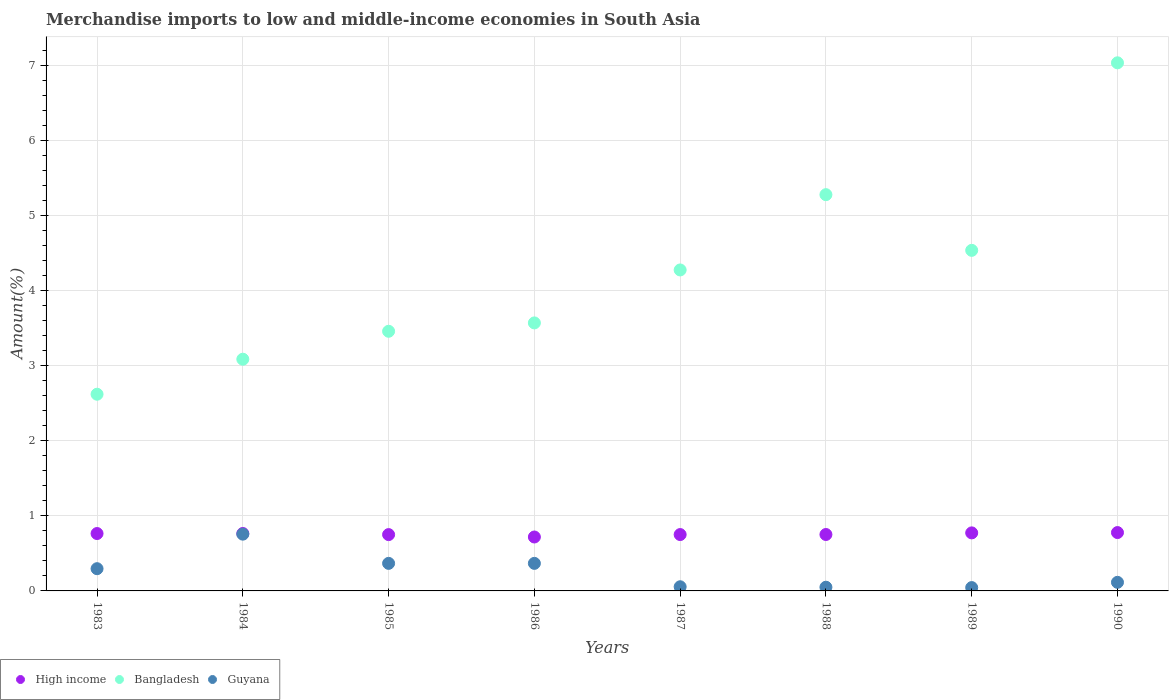What is the percentage of amount earned from merchandise imports in Guyana in 1985?
Give a very brief answer. 0.37. Across all years, what is the maximum percentage of amount earned from merchandise imports in Guyana?
Keep it short and to the point. 0.76. Across all years, what is the minimum percentage of amount earned from merchandise imports in Guyana?
Ensure brevity in your answer.  0.04. In which year was the percentage of amount earned from merchandise imports in Guyana maximum?
Make the answer very short. 1984. What is the total percentage of amount earned from merchandise imports in Bangladesh in the graph?
Your answer should be compact. 33.88. What is the difference between the percentage of amount earned from merchandise imports in High income in 1985 and that in 1990?
Your answer should be compact. -0.03. What is the difference between the percentage of amount earned from merchandise imports in Bangladesh in 1985 and the percentage of amount earned from merchandise imports in Guyana in 1986?
Your answer should be compact. 3.09. What is the average percentage of amount earned from merchandise imports in Guyana per year?
Provide a short and direct response. 0.26. In the year 1988, what is the difference between the percentage of amount earned from merchandise imports in High income and percentage of amount earned from merchandise imports in Guyana?
Offer a terse response. 0.7. In how many years, is the percentage of amount earned from merchandise imports in High income greater than 2.6 %?
Give a very brief answer. 0. What is the ratio of the percentage of amount earned from merchandise imports in Guyana in 1986 to that in 1990?
Your response must be concise. 3.21. Is the percentage of amount earned from merchandise imports in Bangladesh in 1984 less than that in 1986?
Offer a very short reply. Yes. Is the difference between the percentage of amount earned from merchandise imports in High income in 1985 and 1986 greater than the difference between the percentage of amount earned from merchandise imports in Guyana in 1985 and 1986?
Provide a succinct answer. Yes. What is the difference between the highest and the second highest percentage of amount earned from merchandise imports in Bangladesh?
Keep it short and to the point. 1.76. What is the difference between the highest and the lowest percentage of amount earned from merchandise imports in Guyana?
Your response must be concise. 0.71. Is the sum of the percentage of amount earned from merchandise imports in Bangladesh in 1984 and 1988 greater than the maximum percentage of amount earned from merchandise imports in Guyana across all years?
Offer a terse response. Yes. Is it the case that in every year, the sum of the percentage of amount earned from merchandise imports in High income and percentage of amount earned from merchandise imports in Bangladesh  is greater than the percentage of amount earned from merchandise imports in Guyana?
Your response must be concise. Yes. Does the percentage of amount earned from merchandise imports in Guyana monotonically increase over the years?
Make the answer very short. No. Is the percentage of amount earned from merchandise imports in Bangladesh strictly greater than the percentage of amount earned from merchandise imports in High income over the years?
Offer a terse response. Yes. Is the percentage of amount earned from merchandise imports in High income strictly less than the percentage of amount earned from merchandise imports in Guyana over the years?
Ensure brevity in your answer.  No. How many dotlines are there?
Keep it short and to the point. 3. How many years are there in the graph?
Make the answer very short. 8. Are the values on the major ticks of Y-axis written in scientific E-notation?
Make the answer very short. No. Where does the legend appear in the graph?
Provide a short and direct response. Bottom left. How are the legend labels stacked?
Make the answer very short. Horizontal. What is the title of the graph?
Make the answer very short. Merchandise imports to low and middle-income economies in South Asia. What is the label or title of the Y-axis?
Make the answer very short. Amount(%). What is the Amount(%) of High income in 1983?
Make the answer very short. 0.76. What is the Amount(%) of Bangladesh in 1983?
Your answer should be compact. 2.62. What is the Amount(%) of Guyana in 1983?
Provide a short and direct response. 0.3. What is the Amount(%) in High income in 1984?
Your response must be concise. 0.77. What is the Amount(%) in Bangladesh in 1984?
Your response must be concise. 3.09. What is the Amount(%) of Guyana in 1984?
Provide a short and direct response. 0.76. What is the Amount(%) of High income in 1985?
Offer a very short reply. 0.75. What is the Amount(%) in Bangladesh in 1985?
Keep it short and to the point. 3.46. What is the Amount(%) of Guyana in 1985?
Ensure brevity in your answer.  0.37. What is the Amount(%) of High income in 1986?
Make the answer very short. 0.72. What is the Amount(%) of Bangladesh in 1986?
Your response must be concise. 3.57. What is the Amount(%) in Guyana in 1986?
Your response must be concise. 0.37. What is the Amount(%) in High income in 1987?
Your response must be concise. 0.75. What is the Amount(%) of Bangladesh in 1987?
Your answer should be compact. 4.28. What is the Amount(%) in Guyana in 1987?
Provide a succinct answer. 0.06. What is the Amount(%) of High income in 1988?
Your answer should be compact. 0.75. What is the Amount(%) in Bangladesh in 1988?
Provide a short and direct response. 5.28. What is the Amount(%) of Guyana in 1988?
Offer a very short reply. 0.05. What is the Amount(%) in High income in 1989?
Provide a short and direct response. 0.77. What is the Amount(%) of Bangladesh in 1989?
Give a very brief answer. 4.54. What is the Amount(%) of Guyana in 1989?
Offer a terse response. 0.04. What is the Amount(%) in High income in 1990?
Your answer should be very brief. 0.78. What is the Amount(%) of Bangladesh in 1990?
Make the answer very short. 7.04. What is the Amount(%) in Guyana in 1990?
Ensure brevity in your answer.  0.11. Across all years, what is the maximum Amount(%) of High income?
Provide a short and direct response. 0.78. Across all years, what is the maximum Amount(%) in Bangladesh?
Keep it short and to the point. 7.04. Across all years, what is the maximum Amount(%) of Guyana?
Give a very brief answer. 0.76. Across all years, what is the minimum Amount(%) of High income?
Provide a short and direct response. 0.72. Across all years, what is the minimum Amount(%) of Bangladesh?
Offer a terse response. 2.62. Across all years, what is the minimum Amount(%) of Guyana?
Offer a very short reply. 0.04. What is the total Amount(%) in High income in the graph?
Offer a terse response. 6.05. What is the total Amount(%) of Bangladesh in the graph?
Ensure brevity in your answer.  33.88. What is the total Amount(%) in Guyana in the graph?
Offer a terse response. 2.05. What is the difference between the Amount(%) in High income in 1983 and that in 1984?
Keep it short and to the point. -0. What is the difference between the Amount(%) of Bangladesh in 1983 and that in 1984?
Give a very brief answer. -0.47. What is the difference between the Amount(%) in Guyana in 1983 and that in 1984?
Your answer should be compact. -0.46. What is the difference between the Amount(%) in High income in 1983 and that in 1985?
Make the answer very short. 0.01. What is the difference between the Amount(%) in Bangladesh in 1983 and that in 1985?
Provide a short and direct response. -0.84. What is the difference between the Amount(%) of Guyana in 1983 and that in 1985?
Keep it short and to the point. -0.07. What is the difference between the Amount(%) of High income in 1983 and that in 1986?
Your answer should be very brief. 0.05. What is the difference between the Amount(%) in Bangladesh in 1983 and that in 1986?
Offer a very short reply. -0.95. What is the difference between the Amount(%) of Guyana in 1983 and that in 1986?
Offer a terse response. -0.07. What is the difference between the Amount(%) in High income in 1983 and that in 1987?
Ensure brevity in your answer.  0.01. What is the difference between the Amount(%) in Bangladesh in 1983 and that in 1987?
Provide a short and direct response. -1.66. What is the difference between the Amount(%) of Guyana in 1983 and that in 1987?
Give a very brief answer. 0.24. What is the difference between the Amount(%) of High income in 1983 and that in 1988?
Your response must be concise. 0.01. What is the difference between the Amount(%) of Bangladesh in 1983 and that in 1988?
Offer a very short reply. -2.66. What is the difference between the Amount(%) in Guyana in 1983 and that in 1988?
Give a very brief answer. 0.25. What is the difference between the Amount(%) in High income in 1983 and that in 1989?
Make the answer very short. -0.01. What is the difference between the Amount(%) of Bangladesh in 1983 and that in 1989?
Your response must be concise. -1.92. What is the difference between the Amount(%) of Guyana in 1983 and that in 1989?
Offer a very short reply. 0.25. What is the difference between the Amount(%) in High income in 1983 and that in 1990?
Give a very brief answer. -0.01. What is the difference between the Amount(%) of Bangladesh in 1983 and that in 1990?
Your answer should be compact. -4.42. What is the difference between the Amount(%) of Guyana in 1983 and that in 1990?
Ensure brevity in your answer.  0.18. What is the difference between the Amount(%) of High income in 1984 and that in 1985?
Your answer should be compact. 0.01. What is the difference between the Amount(%) of Bangladesh in 1984 and that in 1985?
Your answer should be compact. -0.37. What is the difference between the Amount(%) of Guyana in 1984 and that in 1985?
Your response must be concise. 0.39. What is the difference between the Amount(%) in High income in 1984 and that in 1986?
Keep it short and to the point. 0.05. What is the difference between the Amount(%) in Bangladesh in 1984 and that in 1986?
Make the answer very short. -0.48. What is the difference between the Amount(%) in Guyana in 1984 and that in 1986?
Your response must be concise. 0.39. What is the difference between the Amount(%) in High income in 1984 and that in 1987?
Your response must be concise. 0.01. What is the difference between the Amount(%) in Bangladesh in 1984 and that in 1987?
Make the answer very short. -1.19. What is the difference between the Amount(%) in Guyana in 1984 and that in 1987?
Give a very brief answer. 0.7. What is the difference between the Amount(%) in High income in 1984 and that in 1988?
Ensure brevity in your answer.  0.01. What is the difference between the Amount(%) of Bangladesh in 1984 and that in 1988?
Provide a short and direct response. -2.19. What is the difference between the Amount(%) in Guyana in 1984 and that in 1988?
Your answer should be compact. 0.71. What is the difference between the Amount(%) in High income in 1984 and that in 1989?
Ensure brevity in your answer.  -0.01. What is the difference between the Amount(%) of Bangladesh in 1984 and that in 1989?
Give a very brief answer. -1.45. What is the difference between the Amount(%) of Guyana in 1984 and that in 1989?
Ensure brevity in your answer.  0.71. What is the difference between the Amount(%) of High income in 1984 and that in 1990?
Offer a terse response. -0.01. What is the difference between the Amount(%) of Bangladesh in 1984 and that in 1990?
Offer a very short reply. -3.95. What is the difference between the Amount(%) of Guyana in 1984 and that in 1990?
Offer a terse response. 0.64. What is the difference between the Amount(%) in High income in 1985 and that in 1986?
Offer a terse response. 0.03. What is the difference between the Amount(%) of Bangladesh in 1985 and that in 1986?
Keep it short and to the point. -0.11. What is the difference between the Amount(%) in High income in 1985 and that in 1987?
Provide a succinct answer. -0. What is the difference between the Amount(%) of Bangladesh in 1985 and that in 1987?
Your answer should be very brief. -0.82. What is the difference between the Amount(%) of Guyana in 1985 and that in 1987?
Provide a succinct answer. 0.31. What is the difference between the Amount(%) in High income in 1985 and that in 1988?
Offer a terse response. -0. What is the difference between the Amount(%) in Bangladesh in 1985 and that in 1988?
Make the answer very short. -1.82. What is the difference between the Amount(%) in Guyana in 1985 and that in 1988?
Provide a succinct answer. 0.32. What is the difference between the Amount(%) in High income in 1985 and that in 1989?
Make the answer very short. -0.02. What is the difference between the Amount(%) in Bangladesh in 1985 and that in 1989?
Your answer should be very brief. -1.08. What is the difference between the Amount(%) of Guyana in 1985 and that in 1989?
Make the answer very short. 0.32. What is the difference between the Amount(%) in High income in 1985 and that in 1990?
Provide a succinct answer. -0.03. What is the difference between the Amount(%) in Bangladesh in 1985 and that in 1990?
Your answer should be very brief. -3.58. What is the difference between the Amount(%) in Guyana in 1985 and that in 1990?
Give a very brief answer. 0.25. What is the difference between the Amount(%) in High income in 1986 and that in 1987?
Ensure brevity in your answer.  -0.03. What is the difference between the Amount(%) in Bangladesh in 1986 and that in 1987?
Provide a short and direct response. -0.71. What is the difference between the Amount(%) of Guyana in 1986 and that in 1987?
Provide a succinct answer. 0.31. What is the difference between the Amount(%) of High income in 1986 and that in 1988?
Provide a succinct answer. -0.03. What is the difference between the Amount(%) of Bangladesh in 1986 and that in 1988?
Provide a succinct answer. -1.71. What is the difference between the Amount(%) in Guyana in 1986 and that in 1988?
Offer a very short reply. 0.32. What is the difference between the Amount(%) of High income in 1986 and that in 1989?
Ensure brevity in your answer.  -0.05. What is the difference between the Amount(%) in Bangladesh in 1986 and that in 1989?
Offer a terse response. -0.97. What is the difference between the Amount(%) in Guyana in 1986 and that in 1989?
Your response must be concise. 0.32. What is the difference between the Amount(%) in High income in 1986 and that in 1990?
Keep it short and to the point. -0.06. What is the difference between the Amount(%) of Bangladesh in 1986 and that in 1990?
Your answer should be very brief. -3.47. What is the difference between the Amount(%) of Guyana in 1986 and that in 1990?
Keep it short and to the point. 0.25. What is the difference between the Amount(%) in High income in 1987 and that in 1988?
Make the answer very short. -0. What is the difference between the Amount(%) of Bangladesh in 1987 and that in 1988?
Provide a short and direct response. -1. What is the difference between the Amount(%) in Guyana in 1987 and that in 1988?
Your answer should be compact. 0.01. What is the difference between the Amount(%) of High income in 1987 and that in 1989?
Ensure brevity in your answer.  -0.02. What is the difference between the Amount(%) in Bangladesh in 1987 and that in 1989?
Offer a very short reply. -0.26. What is the difference between the Amount(%) of Guyana in 1987 and that in 1989?
Your answer should be very brief. 0.01. What is the difference between the Amount(%) of High income in 1987 and that in 1990?
Keep it short and to the point. -0.03. What is the difference between the Amount(%) of Bangladesh in 1987 and that in 1990?
Your answer should be compact. -2.76. What is the difference between the Amount(%) of Guyana in 1987 and that in 1990?
Your answer should be compact. -0.06. What is the difference between the Amount(%) in High income in 1988 and that in 1989?
Provide a short and direct response. -0.02. What is the difference between the Amount(%) of Bangladesh in 1988 and that in 1989?
Offer a terse response. 0.74. What is the difference between the Amount(%) in Guyana in 1988 and that in 1989?
Offer a terse response. 0. What is the difference between the Amount(%) of High income in 1988 and that in 1990?
Make the answer very short. -0.03. What is the difference between the Amount(%) in Bangladesh in 1988 and that in 1990?
Your response must be concise. -1.76. What is the difference between the Amount(%) of Guyana in 1988 and that in 1990?
Your answer should be very brief. -0.07. What is the difference between the Amount(%) of High income in 1989 and that in 1990?
Your response must be concise. -0. What is the difference between the Amount(%) in Bangladesh in 1989 and that in 1990?
Your response must be concise. -2.5. What is the difference between the Amount(%) of Guyana in 1989 and that in 1990?
Your answer should be compact. -0.07. What is the difference between the Amount(%) in High income in 1983 and the Amount(%) in Bangladesh in 1984?
Offer a terse response. -2.32. What is the difference between the Amount(%) of High income in 1983 and the Amount(%) of Guyana in 1984?
Offer a very short reply. 0.01. What is the difference between the Amount(%) in Bangladesh in 1983 and the Amount(%) in Guyana in 1984?
Ensure brevity in your answer.  1.86. What is the difference between the Amount(%) in High income in 1983 and the Amount(%) in Bangladesh in 1985?
Provide a succinct answer. -2.7. What is the difference between the Amount(%) of High income in 1983 and the Amount(%) of Guyana in 1985?
Make the answer very short. 0.4. What is the difference between the Amount(%) of Bangladesh in 1983 and the Amount(%) of Guyana in 1985?
Provide a succinct answer. 2.25. What is the difference between the Amount(%) of High income in 1983 and the Amount(%) of Bangladesh in 1986?
Give a very brief answer. -2.81. What is the difference between the Amount(%) in High income in 1983 and the Amount(%) in Guyana in 1986?
Offer a terse response. 0.4. What is the difference between the Amount(%) of Bangladesh in 1983 and the Amount(%) of Guyana in 1986?
Provide a short and direct response. 2.25. What is the difference between the Amount(%) of High income in 1983 and the Amount(%) of Bangladesh in 1987?
Make the answer very short. -3.51. What is the difference between the Amount(%) of High income in 1983 and the Amount(%) of Guyana in 1987?
Your response must be concise. 0.71. What is the difference between the Amount(%) in Bangladesh in 1983 and the Amount(%) in Guyana in 1987?
Your response must be concise. 2.57. What is the difference between the Amount(%) of High income in 1983 and the Amount(%) of Bangladesh in 1988?
Provide a short and direct response. -4.52. What is the difference between the Amount(%) in High income in 1983 and the Amount(%) in Guyana in 1988?
Offer a very short reply. 0.72. What is the difference between the Amount(%) in Bangladesh in 1983 and the Amount(%) in Guyana in 1988?
Provide a short and direct response. 2.57. What is the difference between the Amount(%) of High income in 1983 and the Amount(%) of Bangladesh in 1989?
Ensure brevity in your answer.  -3.77. What is the difference between the Amount(%) in High income in 1983 and the Amount(%) in Guyana in 1989?
Keep it short and to the point. 0.72. What is the difference between the Amount(%) of Bangladesh in 1983 and the Amount(%) of Guyana in 1989?
Offer a very short reply. 2.58. What is the difference between the Amount(%) in High income in 1983 and the Amount(%) in Bangladesh in 1990?
Your answer should be compact. -6.27. What is the difference between the Amount(%) of High income in 1983 and the Amount(%) of Guyana in 1990?
Your answer should be very brief. 0.65. What is the difference between the Amount(%) in Bangladesh in 1983 and the Amount(%) in Guyana in 1990?
Keep it short and to the point. 2.51. What is the difference between the Amount(%) of High income in 1984 and the Amount(%) of Bangladesh in 1985?
Make the answer very short. -2.7. What is the difference between the Amount(%) in High income in 1984 and the Amount(%) in Guyana in 1985?
Offer a very short reply. 0.4. What is the difference between the Amount(%) in Bangladesh in 1984 and the Amount(%) in Guyana in 1985?
Offer a very short reply. 2.72. What is the difference between the Amount(%) in High income in 1984 and the Amount(%) in Bangladesh in 1986?
Your answer should be compact. -2.81. What is the difference between the Amount(%) in High income in 1984 and the Amount(%) in Guyana in 1986?
Give a very brief answer. 0.4. What is the difference between the Amount(%) of Bangladesh in 1984 and the Amount(%) of Guyana in 1986?
Give a very brief answer. 2.72. What is the difference between the Amount(%) of High income in 1984 and the Amount(%) of Bangladesh in 1987?
Give a very brief answer. -3.51. What is the difference between the Amount(%) of High income in 1984 and the Amount(%) of Guyana in 1987?
Keep it short and to the point. 0.71. What is the difference between the Amount(%) in Bangladesh in 1984 and the Amount(%) in Guyana in 1987?
Make the answer very short. 3.03. What is the difference between the Amount(%) of High income in 1984 and the Amount(%) of Bangladesh in 1988?
Your answer should be compact. -4.52. What is the difference between the Amount(%) in High income in 1984 and the Amount(%) in Guyana in 1988?
Make the answer very short. 0.72. What is the difference between the Amount(%) of Bangladesh in 1984 and the Amount(%) of Guyana in 1988?
Your answer should be compact. 3.04. What is the difference between the Amount(%) of High income in 1984 and the Amount(%) of Bangladesh in 1989?
Make the answer very short. -3.77. What is the difference between the Amount(%) of High income in 1984 and the Amount(%) of Guyana in 1989?
Ensure brevity in your answer.  0.72. What is the difference between the Amount(%) in Bangladesh in 1984 and the Amount(%) in Guyana in 1989?
Give a very brief answer. 3.04. What is the difference between the Amount(%) of High income in 1984 and the Amount(%) of Bangladesh in 1990?
Offer a very short reply. -6.27. What is the difference between the Amount(%) in High income in 1984 and the Amount(%) in Guyana in 1990?
Keep it short and to the point. 0.65. What is the difference between the Amount(%) of Bangladesh in 1984 and the Amount(%) of Guyana in 1990?
Your answer should be very brief. 2.97. What is the difference between the Amount(%) in High income in 1985 and the Amount(%) in Bangladesh in 1986?
Keep it short and to the point. -2.82. What is the difference between the Amount(%) of High income in 1985 and the Amount(%) of Guyana in 1986?
Your response must be concise. 0.38. What is the difference between the Amount(%) of Bangladesh in 1985 and the Amount(%) of Guyana in 1986?
Your answer should be very brief. 3.09. What is the difference between the Amount(%) in High income in 1985 and the Amount(%) in Bangladesh in 1987?
Your answer should be very brief. -3.53. What is the difference between the Amount(%) in High income in 1985 and the Amount(%) in Guyana in 1987?
Give a very brief answer. 0.7. What is the difference between the Amount(%) of Bangladesh in 1985 and the Amount(%) of Guyana in 1987?
Your answer should be very brief. 3.41. What is the difference between the Amount(%) in High income in 1985 and the Amount(%) in Bangladesh in 1988?
Keep it short and to the point. -4.53. What is the difference between the Amount(%) in High income in 1985 and the Amount(%) in Guyana in 1988?
Make the answer very short. 0.7. What is the difference between the Amount(%) of Bangladesh in 1985 and the Amount(%) of Guyana in 1988?
Offer a terse response. 3.41. What is the difference between the Amount(%) of High income in 1985 and the Amount(%) of Bangladesh in 1989?
Your answer should be compact. -3.79. What is the difference between the Amount(%) of High income in 1985 and the Amount(%) of Guyana in 1989?
Keep it short and to the point. 0.71. What is the difference between the Amount(%) of Bangladesh in 1985 and the Amount(%) of Guyana in 1989?
Give a very brief answer. 3.42. What is the difference between the Amount(%) in High income in 1985 and the Amount(%) in Bangladesh in 1990?
Your answer should be very brief. -6.29. What is the difference between the Amount(%) of High income in 1985 and the Amount(%) of Guyana in 1990?
Offer a terse response. 0.64. What is the difference between the Amount(%) of Bangladesh in 1985 and the Amount(%) of Guyana in 1990?
Give a very brief answer. 3.35. What is the difference between the Amount(%) in High income in 1986 and the Amount(%) in Bangladesh in 1987?
Ensure brevity in your answer.  -3.56. What is the difference between the Amount(%) in High income in 1986 and the Amount(%) in Guyana in 1987?
Your answer should be compact. 0.66. What is the difference between the Amount(%) in Bangladesh in 1986 and the Amount(%) in Guyana in 1987?
Provide a succinct answer. 3.52. What is the difference between the Amount(%) of High income in 1986 and the Amount(%) of Bangladesh in 1988?
Provide a short and direct response. -4.56. What is the difference between the Amount(%) in High income in 1986 and the Amount(%) in Guyana in 1988?
Offer a terse response. 0.67. What is the difference between the Amount(%) of Bangladesh in 1986 and the Amount(%) of Guyana in 1988?
Ensure brevity in your answer.  3.52. What is the difference between the Amount(%) of High income in 1986 and the Amount(%) of Bangladesh in 1989?
Provide a succinct answer. -3.82. What is the difference between the Amount(%) of High income in 1986 and the Amount(%) of Guyana in 1989?
Keep it short and to the point. 0.67. What is the difference between the Amount(%) in Bangladesh in 1986 and the Amount(%) in Guyana in 1989?
Provide a short and direct response. 3.53. What is the difference between the Amount(%) of High income in 1986 and the Amount(%) of Bangladesh in 1990?
Offer a very short reply. -6.32. What is the difference between the Amount(%) in High income in 1986 and the Amount(%) in Guyana in 1990?
Offer a very short reply. 0.6. What is the difference between the Amount(%) of Bangladesh in 1986 and the Amount(%) of Guyana in 1990?
Offer a very short reply. 3.46. What is the difference between the Amount(%) of High income in 1987 and the Amount(%) of Bangladesh in 1988?
Ensure brevity in your answer.  -4.53. What is the difference between the Amount(%) of High income in 1987 and the Amount(%) of Guyana in 1988?
Your answer should be compact. 0.7. What is the difference between the Amount(%) in Bangladesh in 1987 and the Amount(%) in Guyana in 1988?
Your answer should be very brief. 4.23. What is the difference between the Amount(%) of High income in 1987 and the Amount(%) of Bangladesh in 1989?
Your answer should be very brief. -3.79. What is the difference between the Amount(%) in High income in 1987 and the Amount(%) in Guyana in 1989?
Provide a succinct answer. 0.71. What is the difference between the Amount(%) in Bangladesh in 1987 and the Amount(%) in Guyana in 1989?
Ensure brevity in your answer.  4.23. What is the difference between the Amount(%) in High income in 1987 and the Amount(%) in Bangladesh in 1990?
Make the answer very short. -6.29. What is the difference between the Amount(%) in High income in 1987 and the Amount(%) in Guyana in 1990?
Keep it short and to the point. 0.64. What is the difference between the Amount(%) of Bangladesh in 1987 and the Amount(%) of Guyana in 1990?
Give a very brief answer. 4.16. What is the difference between the Amount(%) of High income in 1988 and the Amount(%) of Bangladesh in 1989?
Provide a short and direct response. -3.79. What is the difference between the Amount(%) in High income in 1988 and the Amount(%) in Guyana in 1989?
Keep it short and to the point. 0.71. What is the difference between the Amount(%) in Bangladesh in 1988 and the Amount(%) in Guyana in 1989?
Keep it short and to the point. 5.24. What is the difference between the Amount(%) in High income in 1988 and the Amount(%) in Bangladesh in 1990?
Your answer should be compact. -6.29. What is the difference between the Amount(%) of High income in 1988 and the Amount(%) of Guyana in 1990?
Keep it short and to the point. 0.64. What is the difference between the Amount(%) in Bangladesh in 1988 and the Amount(%) in Guyana in 1990?
Give a very brief answer. 5.17. What is the difference between the Amount(%) in High income in 1989 and the Amount(%) in Bangladesh in 1990?
Offer a terse response. -6.27. What is the difference between the Amount(%) of High income in 1989 and the Amount(%) of Guyana in 1990?
Your answer should be very brief. 0.66. What is the difference between the Amount(%) in Bangladesh in 1989 and the Amount(%) in Guyana in 1990?
Offer a terse response. 4.42. What is the average Amount(%) in High income per year?
Your answer should be very brief. 0.76. What is the average Amount(%) of Bangladesh per year?
Provide a succinct answer. 4.23. What is the average Amount(%) of Guyana per year?
Your answer should be very brief. 0.26. In the year 1983, what is the difference between the Amount(%) in High income and Amount(%) in Bangladesh?
Your answer should be compact. -1.86. In the year 1983, what is the difference between the Amount(%) in High income and Amount(%) in Guyana?
Your response must be concise. 0.47. In the year 1983, what is the difference between the Amount(%) in Bangladesh and Amount(%) in Guyana?
Make the answer very short. 2.33. In the year 1984, what is the difference between the Amount(%) in High income and Amount(%) in Bangladesh?
Keep it short and to the point. -2.32. In the year 1984, what is the difference between the Amount(%) in High income and Amount(%) in Guyana?
Give a very brief answer. 0.01. In the year 1984, what is the difference between the Amount(%) in Bangladesh and Amount(%) in Guyana?
Ensure brevity in your answer.  2.33. In the year 1985, what is the difference between the Amount(%) in High income and Amount(%) in Bangladesh?
Give a very brief answer. -2.71. In the year 1985, what is the difference between the Amount(%) in High income and Amount(%) in Guyana?
Your answer should be very brief. 0.38. In the year 1985, what is the difference between the Amount(%) in Bangladesh and Amount(%) in Guyana?
Provide a succinct answer. 3.09. In the year 1986, what is the difference between the Amount(%) of High income and Amount(%) of Bangladesh?
Your answer should be very brief. -2.85. In the year 1986, what is the difference between the Amount(%) in High income and Amount(%) in Guyana?
Offer a terse response. 0.35. In the year 1986, what is the difference between the Amount(%) in Bangladesh and Amount(%) in Guyana?
Provide a succinct answer. 3.2. In the year 1987, what is the difference between the Amount(%) in High income and Amount(%) in Bangladesh?
Offer a very short reply. -3.53. In the year 1987, what is the difference between the Amount(%) in High income and Amount(%) in Guyana?
Provide a succinct answer. 0.7. In the year 1987, what is the difference between the Amount(%) of Bangladesh and Amount(%) of Guyana?
Keep it short and to the point. 4.22. In the year 1988, what is the difference between the Amount(%) of High income and Amount(%) of Bangladesh?
Make the answer very short. -4.53. In the year 1988, what is the difference between the Amount(%) of High income and Amount(%) of Guyana?
Your answer should be compact. 0.7. In the year 1988, what is the difference between the Amount(%) of Bangladesh and Amount(%) of Guyana?
Make the answer very short. 5.23. In the year 1989, what is the difference between the Amount(%) in High income and Amount(%) in Bangladesh?
Keep it short and to the point. -3.77. In the year 1989, what is the difference between the Amount(%) in High income and Amount(%) in Guyana?
Your answer should be very brief. 0.73. In the year 1989, what is the difference between the Amount(%) in Bangladesh and Amount(%) in Guyana?
Provide a succinct answer. 4.49. In the year 1990, what is the difference between the Amount(%) of High income and Amount(%) of Bangladesh?
Keep it short and to the point. -6.26. In the year 1990, what is the difference between the Amount(%) in High income and Amount(%) in Guyana?
Make the answer very short. 0.66. In the year 1990, what is the difference between the Amount(%) in Bangladesh and Amount(%) in Guyana?
Ensure brevity in your answer.  6.92. What is the ratio of the Amount(%) of High income in 1983 to that in 1984?
Ensure brevity in your answer.  1. What is the ratio of the Amount(%) of Bangladesh in 1983 to that in 1984?
Offer a very short reply. 0.85. What is the ratio of the Amount(%) in Guyana in 1983 to that in 1984?
Your answer should be very brief. 0.39. What is the ratio of the Amount(%) of Bangladesh in 1983 to that in 1985?
Your response must be concise. 0.76. What is the ratio of the Amount(%) of Guyana in 1983 to that in 1985?
Provide a short and direct response. 0.81. What is the ratio of the Amount(%) in High income in 1983 to that in 1986?
Your response must be concise. 1.06. What is the ratio of the Amount(%) of Bangladesh in 1983 to that in 1986?
Your answer should be compact. 0.73. What is the ratio of the Amount(%) of Guyana in 1983 to that in 1986?
Offer a terse response. 0.81. What is the ratio of the Amount(%) of High income in 1983 to that in 1987?
Keep it short and to the point. 1.02. What is the ratio of the Amount(%) of Bangladesh in 1983 to that in 1987?
Your response must be concise. 0.61. What is the ratio of the Amount(%) of Guyana in 1983 to that in 1987?
Provide a short and direct response. 5.35. What is the ratio of the Amount(%) of High income in 1983 to that in 1988?
Your response must be concise. 1.02. What is the ratio of the Amount(%) in Bangladesh in 1983 to that in 1988?
Make the answer very short. 0.5. What is the ratio of the Amount(%) in Guyana in 1983 to that in 1988?
Give a very brief answer. 6.01. What is the ratio of the Amount(%) of High income in 1983 to that in 1989?
Provide a short and direct response. 0.99. What is the ratio of the Amount(%) of Bangladesh in 1983 to that in 1989?
Keep it short and to the point. 0.58. What is the ratio of the Amount(%) in Guyana in 1983 to that in 1989?
Give a very brief answer. 6.67. What is the ratio of the Amount(%) in High income in 1983 to that in 1990?
Offer a very short reply. 0.98. What is the ratio of the Amount(%) of Bangladesh in 1983 to that in 1990?
Provide a succinct answer. 0.37. What is the ratio of the Amount(%) in Guyana in 1983 to that in 1990?
Offer a very short reply. 2.59. What is the ratio of the Amount(%) in High income in 1984 to that in 1985?
Your answer should be very brief. 1.02. What is the ratio of the Amount(%) in Bangladesh in 1984 to that in 1985?
Offer a very short reply. 0.89. What is the ratio of the Amount(%) of Guyana in 1984 to that in 1985?
Give a very brief answer. 2.06. What is the ratio of the Amount(%) in High income in 1984 to that in 1986?
Provide a short and direct response. 1.06. What is the ratio of the Amount(%) of Bangladesh in 1984 to that in 1986?
Give a very brief answer. 0.86. What is the ratio of the Amount(%) of Guyana in 1984 to that in 1986?
Offer a very short reply. 2.06. What is the ratio of the Amount(%) of High income in 1984 to that in 1987?
Make the answer very short. 1.02. What is the ratio of the Amount(%) of Bangladesh in 1984 to that in 1987?
Offer a very short reply. 0.72. What is the ratio of the Amount(%) of Guyana in 1984 to that in 1987?
Make the answer very short. 13.65. What is the ratio of the Amount(%) of High income in 1984 to that in 1988?
Provide a succinct answer. 1.02. What is the ratio of the Amount(%) in Bangladesh in 1984 to that in 1988?
Offer a terse response. 0.58. What is the ratio of the Amount(%) of Guyana in 1984 to that in 1988?
Your answer should be very brief. 15.33. What is the ratio of the Amount(%) in High income in 1984 to that in 1989?
Keep it short and to the point. 0.99. What is the ratio of the Amount(%) in Bangladesh in 1984 to that in 1989?
Give a very brief answer. 0.68. What is the ratio of the Amount(%) of Guyana in 1984 to that in 1989?
Ensure brevity in your answer.  17.02. What is the ratio of the Amount(%) of High income in 1984 to that in 1990?
Provide a short and direct response. 0.98. What is the ratio of the Amount(%) of Bangladesh in 1984 to that in 1990?
Your response must be concise. 0.44. What is the ratio of the Amount(%) of Guyana in 1984 to that in 1990?
Provide a succinct answer. 6.61. What is the ratio of the Amount(%) in High income in 1985 to that in 1986?
Make the answer very short. 1.04. What is the ratio of the Amount(%) in Bangladesh in 1985 to that in 1986?
Ensure brevity in your answer.  0.97. What is the ratio of the Amount(%) of Bangladesh in 1985 to that in 1987?
Make the answer very short. 0.81. What is the ratio of the Amount(%) of Guyana in 1985 to that in 1987?
Your response must be concise. 6.63. What is the ratio of the Amount(%) in Bangladesh in 1985 to that in 1988?
Keep it short and to the point. 0.66. What is the ratio of the Amount(%) of Guyana in 1985 to that in 1988?
Ensure brevity in your answer.  7.44. What is the ratio of the Amount(%) in High income in 1985 to that in 1989?
Ensure brevity in your answer.  0.97. What is the ratio of the Amount(%) of Bangladesh in 1985 to that in 1989?
Offer a very short reply. 0.76. What is the ratio of the Amount(%) of Guyana in 1985 to that in 1989?
Provide a short and direct response. 8.26. What is the ratio of the Amount(%) of High income in 1985 to that in 1990?
Your response must be concise. 0.96. What is the ratio of the Amount(%) of Bangladesh in 1985 to that in 1990?
Keep it short and to the point. 0.49. What is the ratio of the Amount(%) in Guyana in 1985 to that in 1990?
Keep it short and to the point. 3.21. What is the ratio of the Amount(%) of High income in 1986 to that in 1987?
Provide a succinct answer. 0.96. What is the ratio of the Amount(%) in Bangladesh in 1986 to that in 1987?
Offer a very short reply. 0.83. What is the ratio of the Amount(%) in Guyana in 1986 to that in 1987?
Your answer should be very brief. 6.63. What is the ratio of the Amount(%) of High income in 1986 to that in 1988?
Your answer should be very brief. 0.96. What is the ratio of the Amount(%) of Bangladesh in 1986 to that in 1988?
Your response must be concise. 0.68. What is the ratio of the Amount(%) of Guyana in 1986 to that in 1988?
Keep it short and to the point. 7.44. What is the ratio of the Amount(%) in High income in 1986 to that in 1989?
Offer a terse response. 0.93. What is the ratio of the Amount(%) in Bangladesh in 1986 to that in 1989?
Your answer should be very brief. 0.79. What is the ratio of the Amount(%) of Guyana in 1986 to that in 1989?
Your answer should be compact. 8.26. What is the ratio of the Amount(%) of High income in 1986 to that in 1990?
Keep it short and to the point. 0.92. What is the ratio of the Amount(%) in Bangladesh in 1986 to that in 1990?
Give a very brief answer. 0.51. What is the ratio of the Amount(%) in Guyana in 1986 to that in 1990?
Make the answer very short. 3.21. What is the ratio of the Amount(%) of High income in 1987 to that in 1988?
Provide a succinct answer. 1. What is the ratio of the Amount(%) of Bangladesh in 1987 to that in 1988?
Offer a very short reply. 0.81. What is the ratio of the Amount(%) of Guyana in 1987 to that in 1988?
Your response must be concise. 1.12. What is the ratio of the Amount(%) of High income in 1987 to that in 1989?
Keep it short and to the point. 0.97. What is the ratio of the Amount(%) in Bangladesh in 1987 to that in 1989?
Ensure brevity in your answer.  0.94. What is the ratio of the Amount(%) of Guyana in 1987 to that in 1989?
Your answer should be compact. 1.25. What is the ratio of the Amount(%) in High income in 1987 to that in 1990?
Keep it short and to the point. 0.97. What is the ratio of the Amount(%) of Bangladesh in 1987 to that in 1990?
Offer a terse response. 0.61. What is the ratio of the Amount(%) in Guyana in 1987 to that in 1990?
Provide a succinct answer. 0.48. What is the ratio of the Amount(%) in High income in 1988 to that in 1989?
Give a very brief answer. 0.97. What is the ratio of the Amount(%) in Bangladesh in 1988 to that in 1989?
Your response must be concise. 1.16. What is the ratio of the Amount(%) in Guyana in 1988 to that in 1989?
Offer a terse response. 1.11. What is the ratio of the Amount(%) in High income in 1988 to that in 1990?
Give a very brief answer. 0.97. What is the ratio of the Amount(%) of Bangladesh in 1988 to that in 1990?
Offer a terse response. 0.75. What is the ratio of the Amount(%) in Guyana in 1988 to that in 1990?
Provide a short and direct response. 0.43. What is the ratio of the Amount(%) in Bangladesh in 1989 to that in 1990?
Your response must be concise. 0.64. What is the ratio of the Amount(%) in Guyana in 1989 to that in 1990?
Your response must be concise. 0.39. What is the difference between the highest and the second highest Amount(%) of High income?
Your response must be concise. 0. What is the difference between the highest and the second highest Amount(%) of Bangladesh?
Your answer should be compact. 1.76. What is the difference between the highest and the second highest Amount(%) in Guyana?
Your answer should be very brief. 0.39. What is the difference between the highest and the lowest Amount(%) of High income?
Provide a succinct answer. 0.06. What is the difference between the highest and the lowest Amount(%) in Bangladesh?
Provide a succinct answer. 4.42. What is the difference between the highest and the lowest Amount(%) of Guyana?
Offer a terse response. 0.71. 